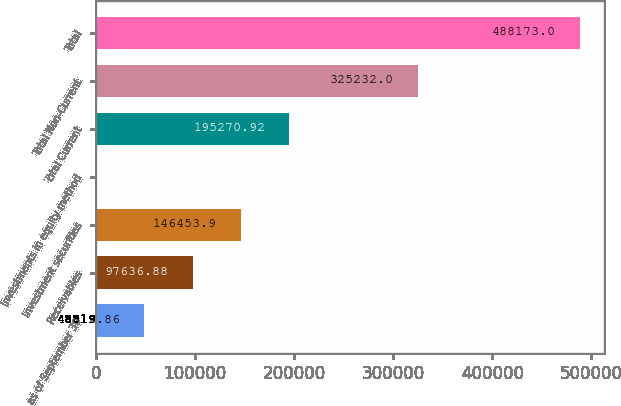<chart> <loc_0><loc_0><loc_500><loc_500><bar_chart><fcel>as of September 30<fcel>Receivables<fcel>Investment securities<fcel>Investments in equity method<fcel>Total Current<fcel>Total Non-Current<fcel>Total<nl><fcel>48819.9<fcel>97636.9<fcel>146454<fcel>2.84<fcel>195271<fcel>325232<fcel>488173<nl></chart> 